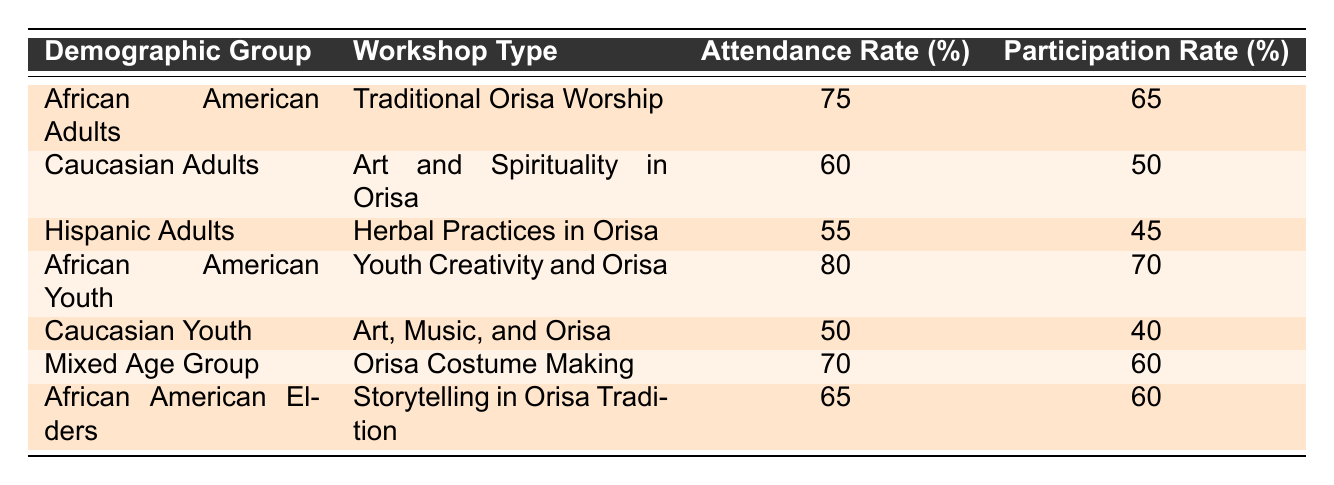What is the attendance rate for African American Adults in Traditional Orisa Worship? The table shows that the attendance rate for African American Adults in the Traditional Orisa Worship workshop is 75%.
Answer: 75 What are the participation rates for Hispanic Adults in Herbal Practices in Orisa? According to the table, the participation rate for Hispanic Adults in the Herbal Practices in Orisa workshop is 45%.
Answer: 45 Which demographic group has the highest attendance rate? After comparing the attendance rates, African American Youth have the highest attendance rate at 80%.
Answer: 80 What is the average attendance rate across all demographic groups? To find the average attendance rate, add the attendance rates: (75 + 60 + 55 + 80 + 50 + 70 + 65) = 455. Dividing this sum by the number of groups (7): 455 / 7 = approximately 65.71.
Answer: 65.71 Did Caucasian Youth have a higher participation rate than Hispanic Adults? The table indicates that Caucasian Youth had a participation rate of 40%, while Hispanic Adults had 45%. Therefore, Caucasian Youth did not have a higher participation rate.
Answer: No Is the participation rate for African American Elders in Storytelling in Orisa Tradition equal to 60%? The table shows that the participation rate for African American Elders in that workshop is indeed 60%, confirming the statement as true.
Answer: Yes What is the difference in attendance rates between Mixed Age Group and Caucasian Adults? The attendance rate for Mixed Age Group is 70% and for Caucasian Adults is 60%. The difference is 70 - 60 = 10.
Answer: 10 How many demographic groups have an attendance rate below 60%? From the table, we see that two groups, Caucasian Youth (50%) and Hispanic Adults (55%), have attendance rates below 60%. Therefore, there are 2 groups.
Answer: 2 What is the total participation rate for all youth workshops? The youth workshops are Youth Creativity and Orisa with a participation rate of 70% and Art, Music, and Orisa with 40%. The total is 70 + 40 = 110%.
Answer: 110 Which demographic group has the lowest attendance rate in workshops about Orisa? The attendance rate for Caucasian Youth is the lowest at 50% when compared to other groups in the table.
Answer: 50 